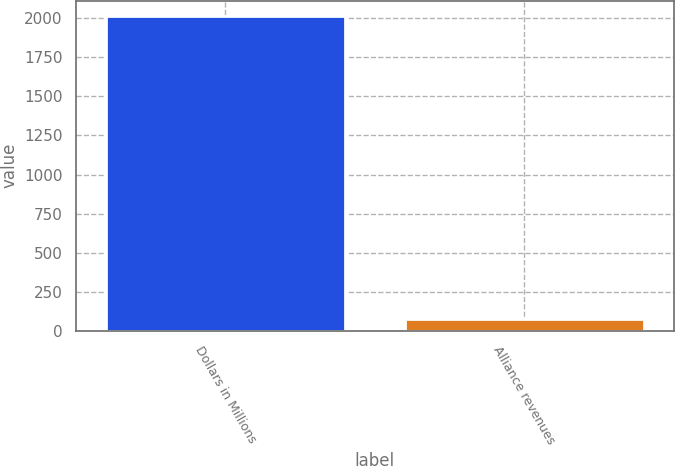Convert chart. <chart><loc_0><loc_0><loc_500><loc_500><bar_chart><fcel>Dollars in Millions<fcel>Alliance revenues<nl><fcel>2013<fcel>74<nl></chart> 